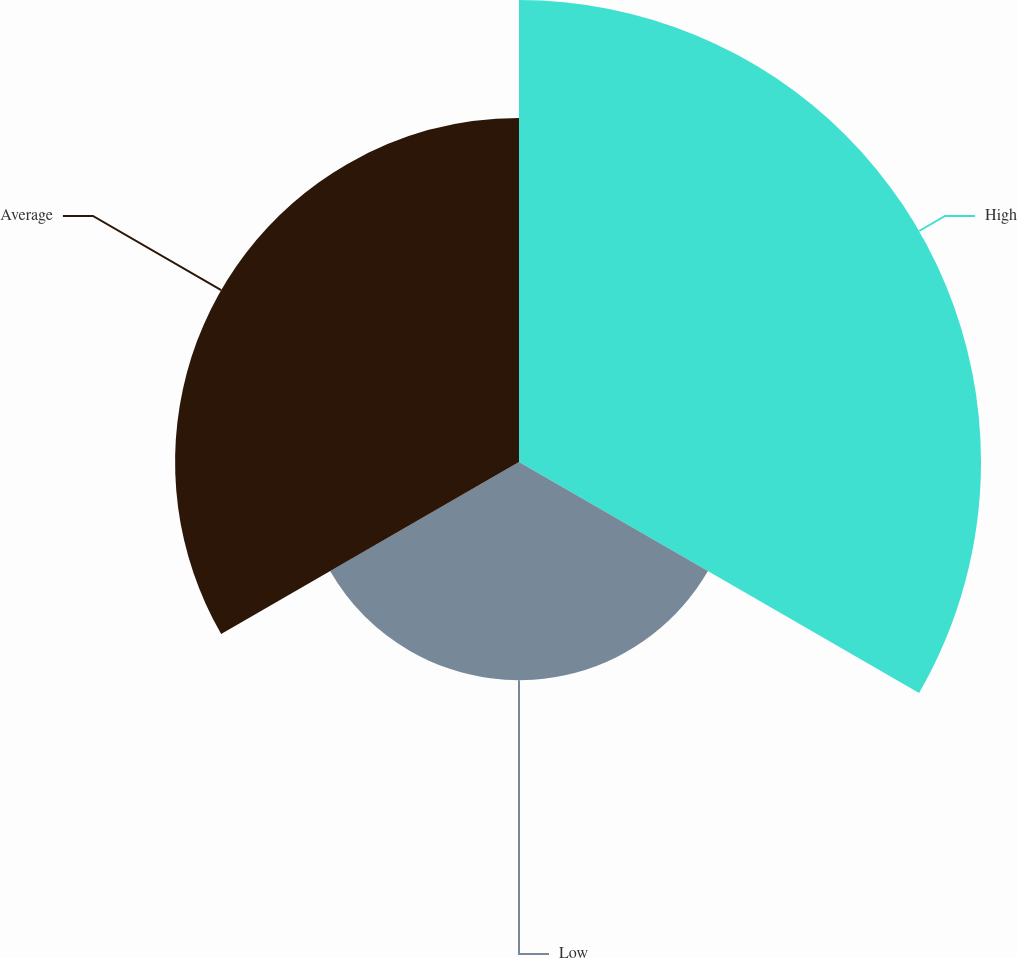Convert chart to OTSL. <chart><loc_0><loc_0><loc_500><loc_500><pie_chart><fcel>High<fcel>Low<fcel>Average<nl><fcel>45.11%<fcel>21.3%<fcel>33.58%<nl></chart> 